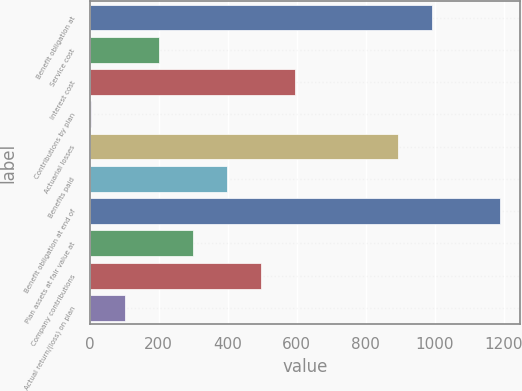<chart> <loc_0><loc_0><loc_500><loc_500><bar_chart><fcel>Benefit obligation at<fcel>Service cost<fcel>Interest cost<fcel>Contributions by plan<fcel>Actuarial losses<fcel>Benefits paid<fcel>Benefit obligation at end of<fcel>Plan assets at fair value at<fcel>Company contributions<fcel>Actual return/(loss) on plan<nl><fcel>991<fcel>202.2<fcel>596.6<fcel>5<fcel>892.4<fcel>399.4<fcel>1188.2<fcel>300.8<fcel>498<fcel>103.6<nl></chart> 